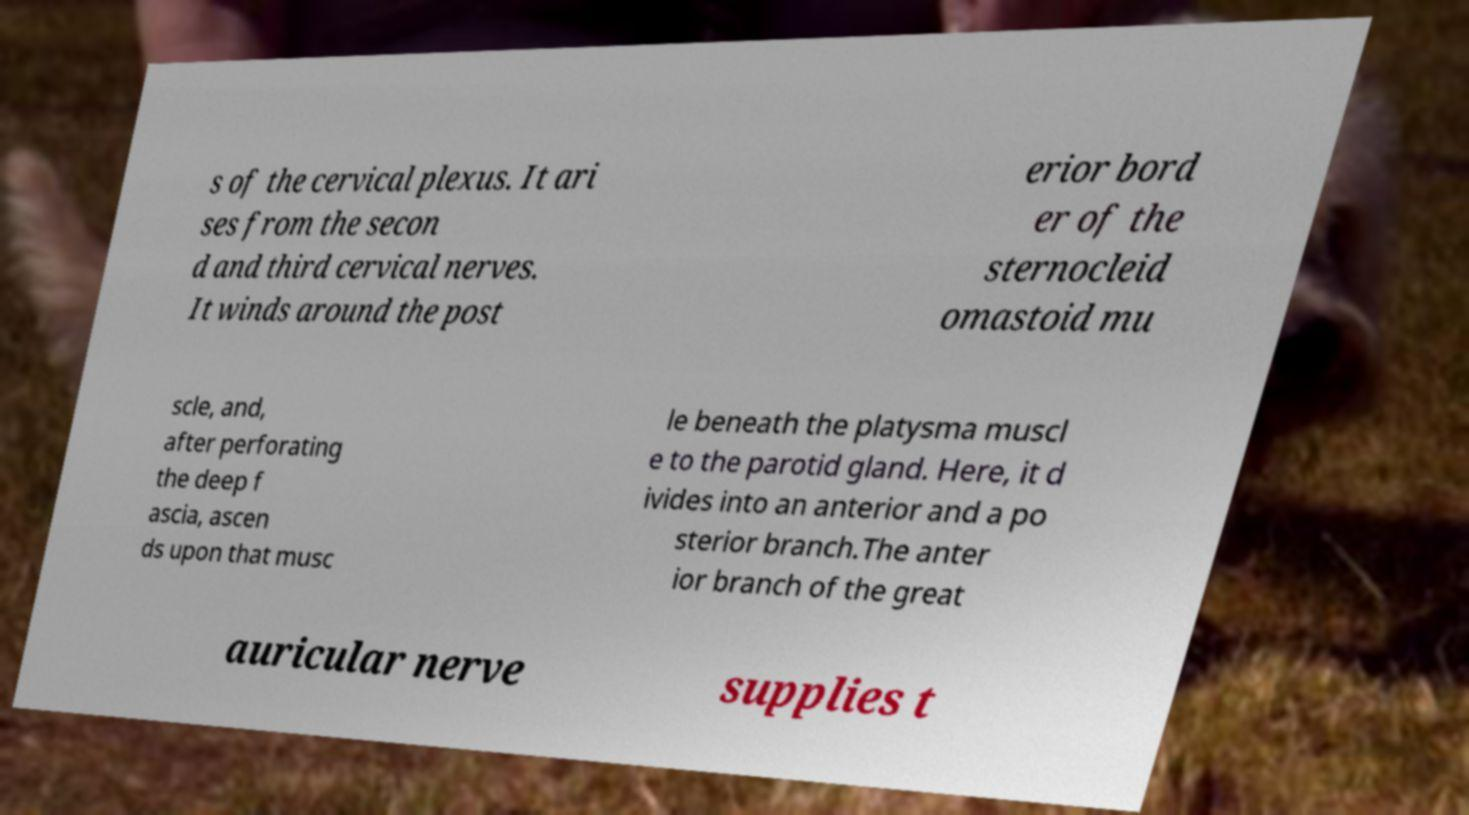Please identify and transcribe the text found in this image. s of the cervical plexus. It ari ses from the secon d and third cervical nerves. It winds around the post erior bord er of the sternocleid omastoid mu scle, and, after perforating the deep f ascia, ascen ds upon that musc le beneath the platysma muscl e to the parotid gland. Here, it d ivides into an anterior and a po sterior branch.The anter ior branch of the great auricular nerve supplies t 